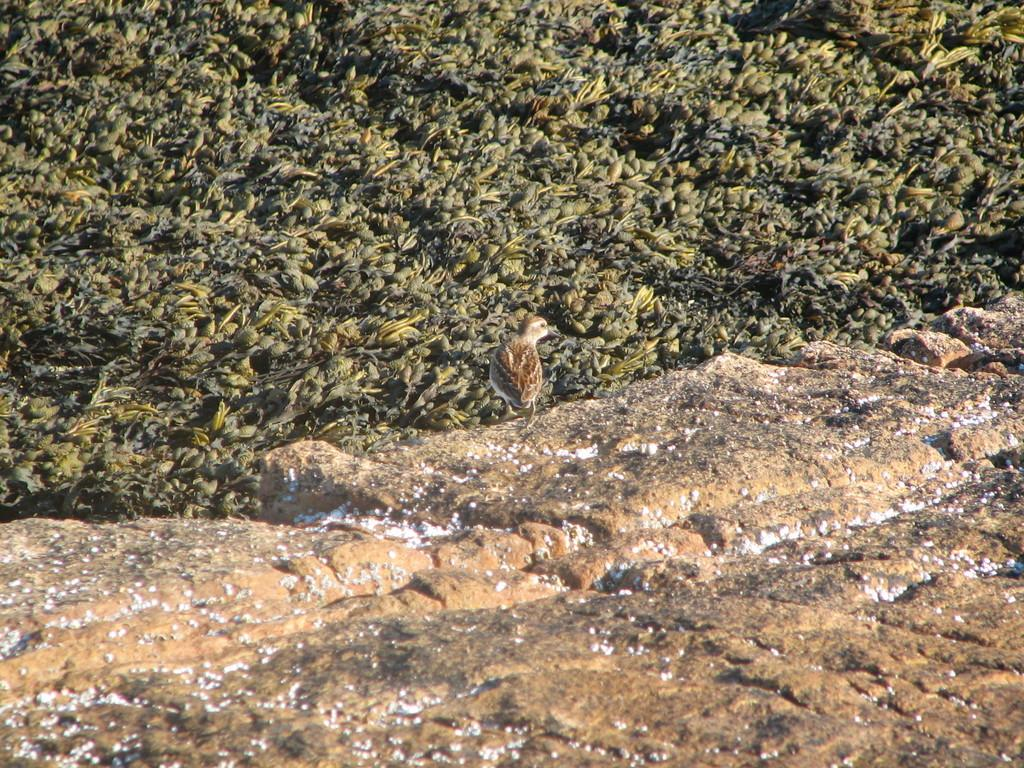What animal can be seen in the image? There is a bird sitting on a rock in the image. Where is the rock located in the image? The rock is at the bottom of the image. What type of vegetation is visible in the background of the image? There is grass in the background of the image. How many pigs are running in the grass in the image? There are no pigs present in the image; it features a bird sitting on a rock with grass in the background. 